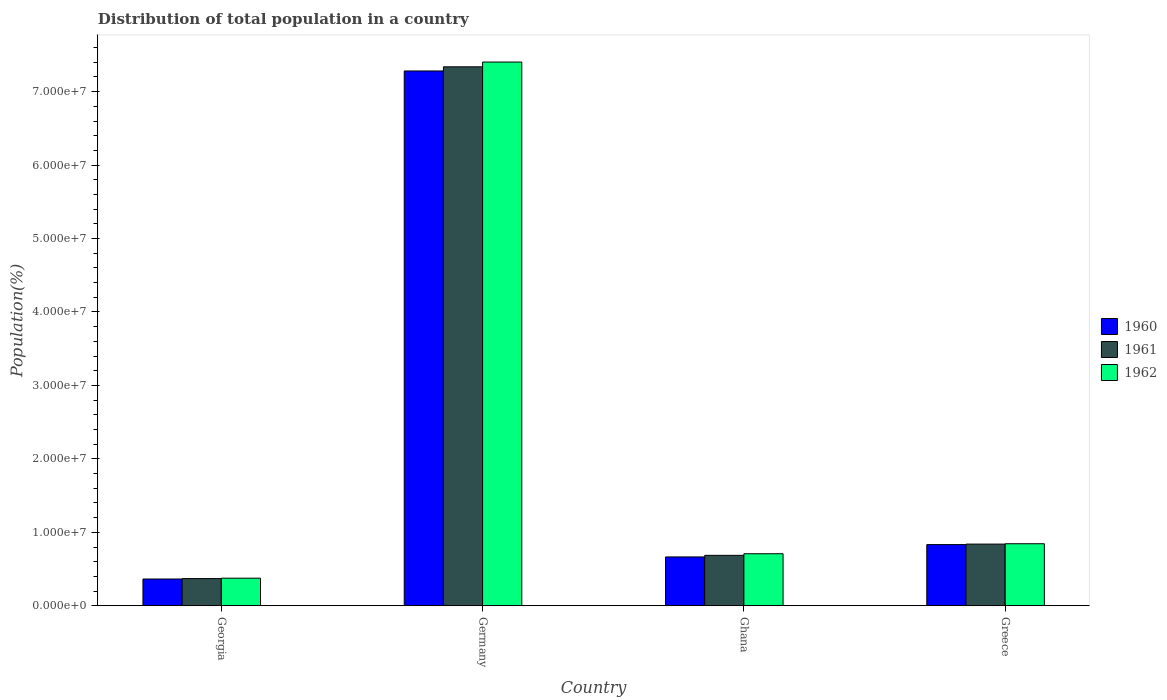How many different coloured bars are there?
Provide a succinct answer. 3. Are the number of bars per tick equal to the number of legend labels?
Offer a very short reply. Yes. Are the number of bars on each tick of the X-axis equal?
Your answer should be very brief. Yes. How many bars are there on the 3rd tick from the right?
Give a very brief answer. 3. What is the label of the 1st group of bars from the left?
Give a very brief answer. Georgia. In how many cases, is the number of bars for a given country not equal to the number of legend labels?
Your response must be concise. 0. What is the population of in 1960 in Germany?
Your response must be concise. 7.28e+07. Across all countries, what is the maximum population of in 1961?
Your response must be concise. 7.34e+07. Across all countries, what is the minimum population of in 1962?
Your answer should be compact. 3.76e+06. In which country was the population of in 1961 maximum?
Offer a terse response. Germany. In which country was the population of in 1962 minimum?
Offer a very short reply. Georgia. What is the total population of in 1960 in the graph?
Keep it short and to the point. 9.14e+07. What is the difference between the population of in 1961 in Georgia and that in Greece?
Ensure brevity in your answer.  -4.69e+06. What is the difference between the population of in 1960 in Ghana and the population of in 1962 in Germany?
Offer a terse response. -6.74e+07. What is the average population of in 1961 per country?
Provide a short and direct response. 2.31e+07. What is the difference between the population of of/in 1961 and population of of/in 1960 in Ghana?
Your answer should be very brief. 2.14e+05. What is the ratio of the population of in 1960 in Ghana to that in Greece?
Make the answer very short. 0.8. Is the population of in 1961 in Georgia less than that in Greece?
Make the answer very short. Yes. What is the difference between the highest and the second highest population of in 1960?
Keep it short and to the point. -6.62e+07. What is the difference between the highest and the lowest population of in 1961?
Keep it short and to the point. 6.97e+07. In how many countries, is the population of in 1961 greater than the average population of in 1961 taken over all countries?
Make the answer very short. 1. What does the 1st bar from the right in Germany represents?
Your response must be concise. 1962. Is it the case that in every country, the sum of the population of in 1961 and population of in 1960 is greater than the population of in 1962?
Your answer should be very brief. Yes. What is the difference between two consecutive major ticks on the Y-axis?
Offer a terse response. 1.00e+07. Are the values on the major ticks of Y-axis written in scientific E-notation?
Provide a short and direct response. Yes. Does the graph contain any zero values?
Make the answer very short. No. Does the graph contain grids?
Ensure brevity in your answer.  No. How are the legend labels stacked?
Provide a short and direct response. Vertical. What is the title of the graph?
Your answer should be compact. Distribution of total population in a country. What is the label or title of the X-axis?
Provide a short and direct response. Country. What is the label or title of the Y-axis?
Your response must be concise. Population(%). What is the Population(%) of 1960 in Georgia?
Your answer should be very brief. 3.65e+06. What is the Population(%) of 1961 in Georgia?
Your answer should be compact. 3.70e+06. What is the Population(%) in 1962 in Georgia?
Provide a short and direct response. 3.76e+06. What is the Population(%) in 1960 in Germany?
Make the answer very short. 7.28e+07. What is the Population(%) in 1961 in Germany?
Offer a terse response. 7.34e+07. What is the Population(%) in 1962 in Germany?
Your response must be concise. 7.40e+07. What is the Population(%) of 1960 in Ghana?
Ensure brevity in your answer.  6.65e+06. What is the Population(%) in 1961 in Ghana?
Your answer should be compact. 6.87e+06. What is the Population(%) of 1962 in Ghana?
Keep it short and to the point. 7.09e+06. What is the Population(%) in 1960 in Greece?
Ensure brevity in your answer.  8.33e+06. What is the Population(%) in 1961 in Greece?
Provide a short and direct response. 8.40e+06. What is the Population(%) in 1962 in Greece?
Ensure brevity in your answer.  8.45e+06. Across all countries, what is the maximum Population(%) in 1960?
Your answer should be very brief. 7.28e+07. Across all countries, what is the maximum Population(%) in 1961?
Provide a short and direct response. 7.34e+07. Across all countries, what is the maximum Population(%) of 1962?
Your response must be concise. 7.40e+07. Across all countries, what is the minimum Population(%) of 1960?
Offer a terse response. 3.65e+06. Across all countries, what is the minimum Population(%) of 1961?
Give a very brief answer. 3.70e+06. Across all countries, what is the minimum Population(%) in 1962?
Keep it short and to the point. 3.76e+06. What is the total Population(%) of 1960 in the graph?
Your response must be concise. 9.14e+07. What is the total Population(%) in 1961 in the graph?
Offer a terse response. 9.23e+07. What is the total Population(%) of 1962 in the graph?
Make the answer very short. 9.33e+07. What is the difference between the Population(%) in 1960 in Georgia and that in Germany?
Give a very brief answer. -6.92e+07. What is the difference between the Population(%) of 1961 in Georgia and that in Germany?
Offer a very short reply. -6.97e+07. What is the difference between the Population(%) in 1962 in Georgia and that in Germany?
Your answer should be compact. -7.03e+07. What is the difference between the Population(%) in 1960 in Georgia and that in Ghana?
Your answer should be compact. -3.01e+06. What is the difference between the Population(%) of 1961 in Georgia and that in Ghana?
Give a very brief answer. -3.16e+06. What is the difference between the Population(%) of 1962 in Georgia and that in Ghana?
Offer a terse response. -3.33e+06. What is the difference between the Population(%) in 1960 in Georgia and that in Greece?
Your answer should be very brief. -4.69e+06. What is the difference between the Population(%) of 1961 in Georgia and that in Greece?
Your response must be concise. -4.69e+06. What is the difference between the Population(%) of 1962 in Georgia and that in Greece?
Ensure brevity in your answer.  -4.69e+06. What is the difference between the Population(%) of 1960 in Germany and that in Ghana?
Your answer should be compact. 6.62e+07. What is the difference between the Population(%) of 1961 in Germany and that in Ghana?
Ensure brevity in your answer.  6.65e+07. What is the difference between the Population(%) of 1962 in Germany and that in Ghana?
Provide a short and direct response. 6.69e+07. What is the difference between the Population(%) in 1960 in Germany and that in Greece?
Your answer should be compact. 6.45e+07. What is the difference between the Population(%) in 1961 in Germany and that in Greece?
Make the answer very short. 6.50e+07. What is the difference between the Population(%) of 1962 in Germany and that in Greece?
Ensure brevity in your answer.  6.56e+07. What is the difference between the Population(%) in 1960 in Ghana and that in Greece?
Keep it short and to the point. -1.68e+06. What is the difference between the Population(%) in 1961 in Ghana and that in Greece?
Your answer should be very brief. -1.53e+06. What is the difference between the Population(%) in 1962 in Ghana and that in Greece?
Your response must be concise. -1.36e+06. What is the difference between the Population(%) in 1960 in Georgia and the Population(%) in 1961 in Germany?
Make the answer very short. -6.97e+07. What is the difference between the Population(%) in 1960 in Georgia and the Population(%) in 1962 in Germany?
Ensure brevity in your answer.  -7.04e+07. What is the difference between the Population(%) in 1961 in Georgia and the Population(%) in 1962 in Germany?
Offer a terse response. -7.03e+07. What is the difference between the Population(%) in 1960 in Georgia and the Population(%) in 1961 in Ghana?
Your answer should be very brief. -3.22e+06. What is the difference between the Population(%) in 1960 in Georgia and the Population(%) in 1962 in Ghana?
Your answer should be compact. -3.44e+06. What is the difference between the Population(%) of 1961 in Georgia and the Population(%) of 1962 in Ghana?
Your answer should be compact. -3.38e+06. What is the difference between the Population(%) in 1960 in Georgia and the Population(%) in 1961 in Greece?
Make the answer very short. -4.75e+06. What is the difference between the Population(%) in 1960 in Georgia and the Population(%) in 1962 in Greece?
Offer a terse response. -4.80e+06. What is the difference between the Population(%) in 1961 in Georgia and the Population(%) in 1962 in Greece?
Offer a very short reply. -4.74e+06. What is the difference between the Population(%) in 1960 in Germany and the Population(%) in 1961 in Ghana?
Ensure brevity in your answer.  6.59e+07. What is the difference between the Population(%) of 1960 in Germany and the Population(%) of 1962 in Ghana?
Provide a succinct answer. 6.57e+07. What is the difference between the Population(%) in 1961 in Germany and the Population(%) in 1962 in Ghana?
Give a very brief answer. 6.63e+07. What is the difference between the Population(%) of 1960 in Germany and the Population(%) of 1961 in Greece?
Provide a short and direct response. 6.44e+07. What is the difference between the Population(%) of 1960 in Germany and the Population(%) of 1962 in Greece?
Your answer should be very brief. 6.44e+07. What is the difference between the Population(%) in 1961 in Germany and the Population(%) in 1962 in Greece?
Make the answer very short. 6.49e+07. What is the difference between the Population(%) of 1960 in Ghana and the Population(%) of 1961 in Greece?
Give a very brief answer. -1.75e+06. What is the difference between the Population(%) of 1960 in Ghana and the Population(%) of 1962 in Greece?
Your response must be concise. -1.80e+06. What is the difference between the Population(%) of 1961 in Ghana and the Population(%) of 1962 in Greece?
Offer a terse response. -1.58e+06. What is the average Population(%) in 1960 per country?
Provide a short and direct response. 2.29e+07. What is the average Population(%) in 1961 per country?
Offer a terse response. 2.31e+07. What is the average Population(%) in 1962 per country?
Your answer should be very brief. 2.33e+07. What is the difference between the Population(%) of 1960 and Population(%) of 1961 in Georgia?
Offer a terse response. -5.80e+04. What is the difference between the Population(%) of 1960 and Population(%) of 1962 in Georgia?
Offer a very short reply. -1.15e+05. What is the difference between the Population(%) of 1961 and Population(%) of 1962 in Georgia?
Offer a terse response. -5.67e+04. What is the difference between the Population(%) in 1960 and Population(%) in 1961 in Germany?
Provide a succinct answer. -5.63e+05. What is the difference between the Population(%) in 1960 and Population(%) in 1962 in Germany?
Make the answer very short. -1.21e+06. What is the difference between the Population(%) in 1961 and Population(%) in 1962 in Germany?
Give a very brief answer. -6.48e+05. What is the difference between the Population(%) of 1960 and Population(%) of 1961 in Ghana?
Offer a terse response. -2.14e+05. What is the difference between the Population(%) of 1960 and Population(%) of 1962 in Ghana?
Offer a terse response. -4.33e+05. What is the difference between the Population(%) in 1961 and Population(%) in 1962 in Ghana?
Give a very brief answer. -2.19e+05. What is the difference between the Population(%) of 1960 and Population(%) of 1961 in Greece?
Offer a very short reply. -6.63e+04. What is the difference between the Population(%) of 1960 and Population(%) of 1962 in Greece?
Offer a terse response. -1.17e+05. What is the difference between the Population(%) in 1961 and Population(%) in 1962 in Greece?
Your answer should be very brief. -5.02e+04. What is the ratio of the Population(%) in 1960 in Georgia to that in Germany?
Provide a short and direct response. 0.05. What is the ratio of the Population(%) of 1961 in Georgia to that in Germany?
Ensure brevity in your answer.  0.05. What is the ratio of the Population(%) in 1962 in Georgia to that in Germany?
Your answer should be very brief. 0.05. What is the ratio of the Population(%) of 1960 in Georgia to that in Ghana?
Keep it short and to the point. 0.55. What is the ratio of the Population(%) in 1961 in Georgia to that in Ghana?
Provide a succinct answer. 0.54. What is the ratio of the Population(%) of 1962 in Georgia to that in Ghana?
Your answer should be compact. 0.53. What is the ratio of the Population(%) in 1960 in Georgia to that in Greece?
Give a very brief answer. 0.44. What is the ratio of the Population(%) in 1961 in Georgia to that in Greece?
Your answer should be very brief. 0.44. What is the ratio of the Population(%) in 1962 in Georgia to that in Greece?
Make the answer very short. 0.45. What is the ratio of the Population(%) of 1960 in Germany to that in Ghana?
Give a very brief answer. 10.95. What is the ratio of the Population(%) of 1961 in Germany to that in Ghana?
Your answer should be compact. 10.69. What is the ratio of the Population(%) in 1962 in Germany to that in Ghana?
Your response must be concise. 10.45. What is the ratio of the Population(%) in 1960 in Germany to that in Greece?
Offer a very short reply. 8.74. What is the ratio of the Population(%) of 1961 in Germany to that in Greece?
Make the answer very short. 8.74. What is the ratio of the Population(%) of 1962 in Germany to that in Greece?
Provide a succinct answer. 8.76. What is the ratio of the Population(%) in 1960 in Ghana to that in Greece?
Provide a short and direct response. 0.8. What is the ratio of the Population(%) in 1961 in Ghana to that in Greece?
Your answer should be very brief. 0.82. What is the ratio of the Population(%) in 1962 in Ghana to that in Greece?
Provide a succinct answer. 0.84. What is the difference between the highest and the second highest Population(%) in 1960?
Provide a short and direct response. 6.45e+07. What is the difference between the highest and the second highest Population(%) in 1961?
Make the answer very short. 6.50e+07. What is the difference between the highest and the second highest Population(%) of 1962?
Offer a terse response. 6.56e+07. What is the difference between the highest and the lowest Population(%) in 1960?
Ensure brevity in your answer.  6.92e+07. What is the difference between the highest and the lowest Population(%) in 1961?
Offer a terse response. 6.97e+07. What is the difference between the highest and the lowest Population(%) in 1962?
Your answer should be very brief. 7.03e+07. 